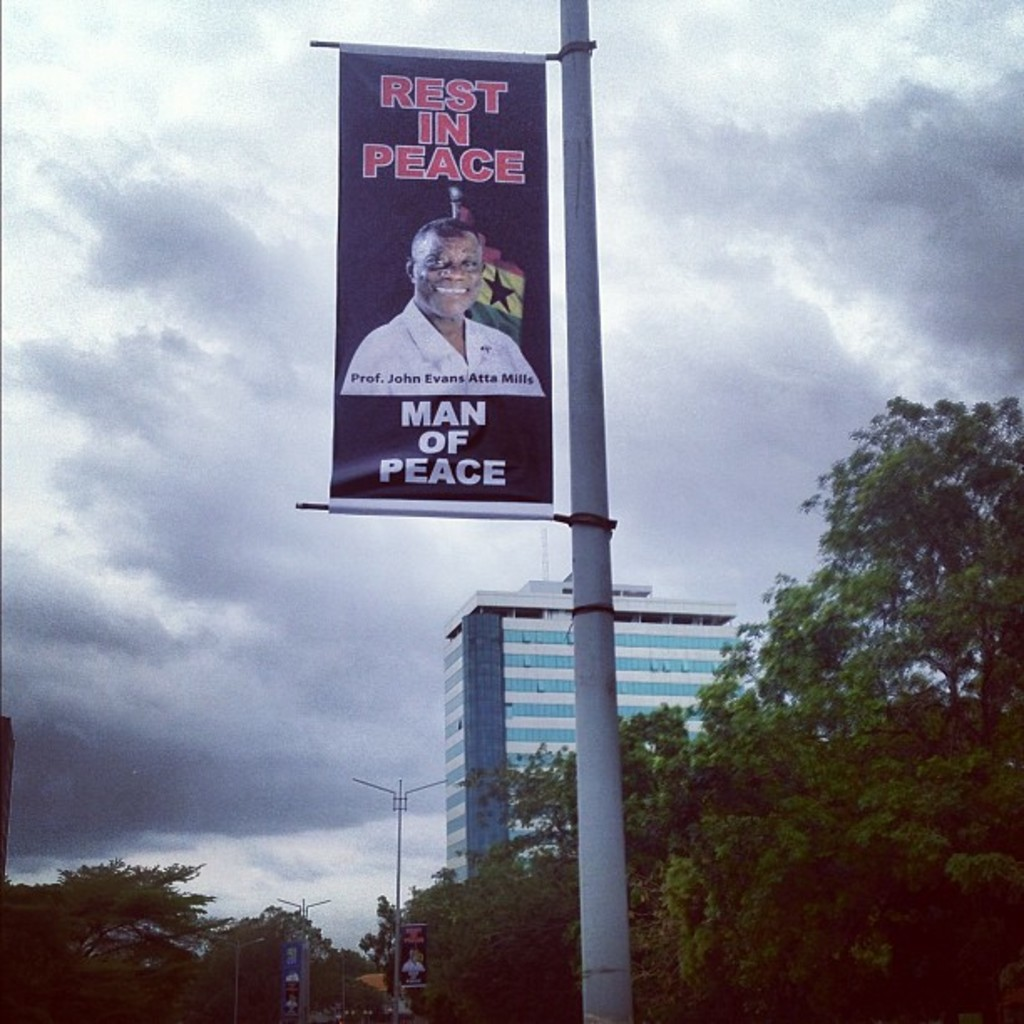Who was Professor John Evans Atta Mills and why is he referred to as a 'Man of Peace' in this banner? Professor John Evans Atta Mills was a respected Ghanaian politician and scholar, who served as the President of Ghana from 2009 until his death in 2012. He was known for his commitment to peace and democratic governance, earning him the epithet 'Man of Peace'. The banner reflects the public's reverence for his peaceful and diplomatic approach during his tenure. 